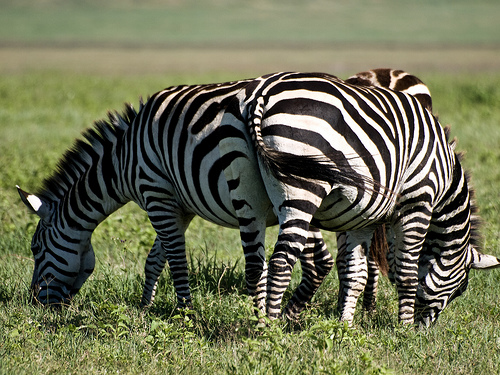Can you describe the habitat in which these zebras are found? The zebras are in a grassland habitat, which is typical for these animals. It's a flat, open terrain with ample grass for grazing, indicative of a savanna ecosystem, likely in Africa where zebras are indigenous. 